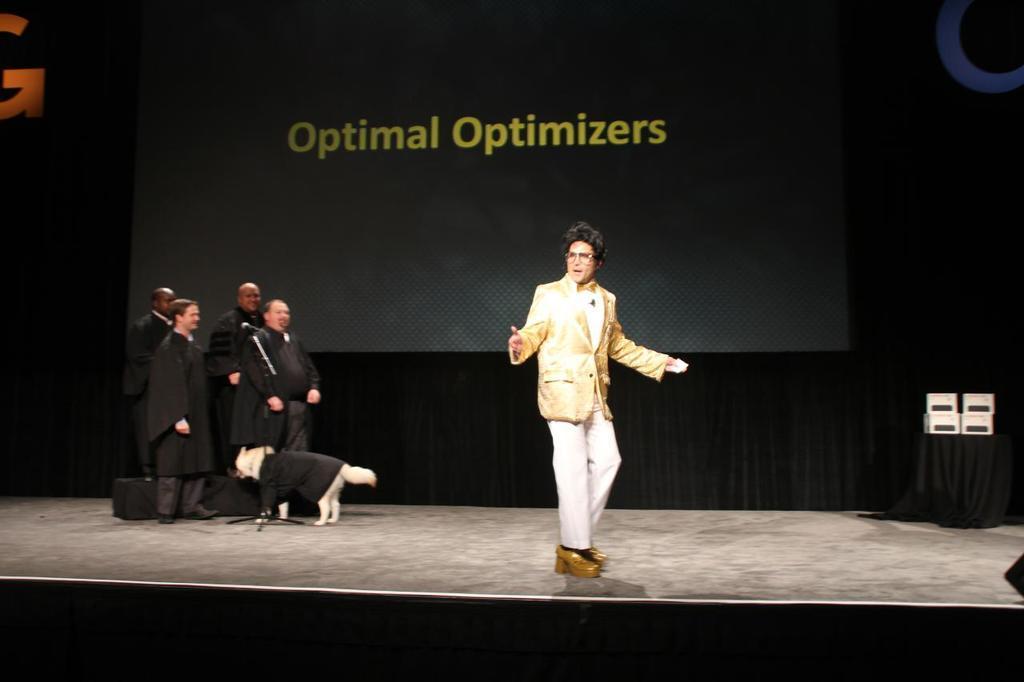In one or two sentences, can you explain what this image depicts? In this picture there is a stage in the center of the image and there are group of people those who are standing on the left side of the image and a dog, there is a man who is standing in the center of the image. 